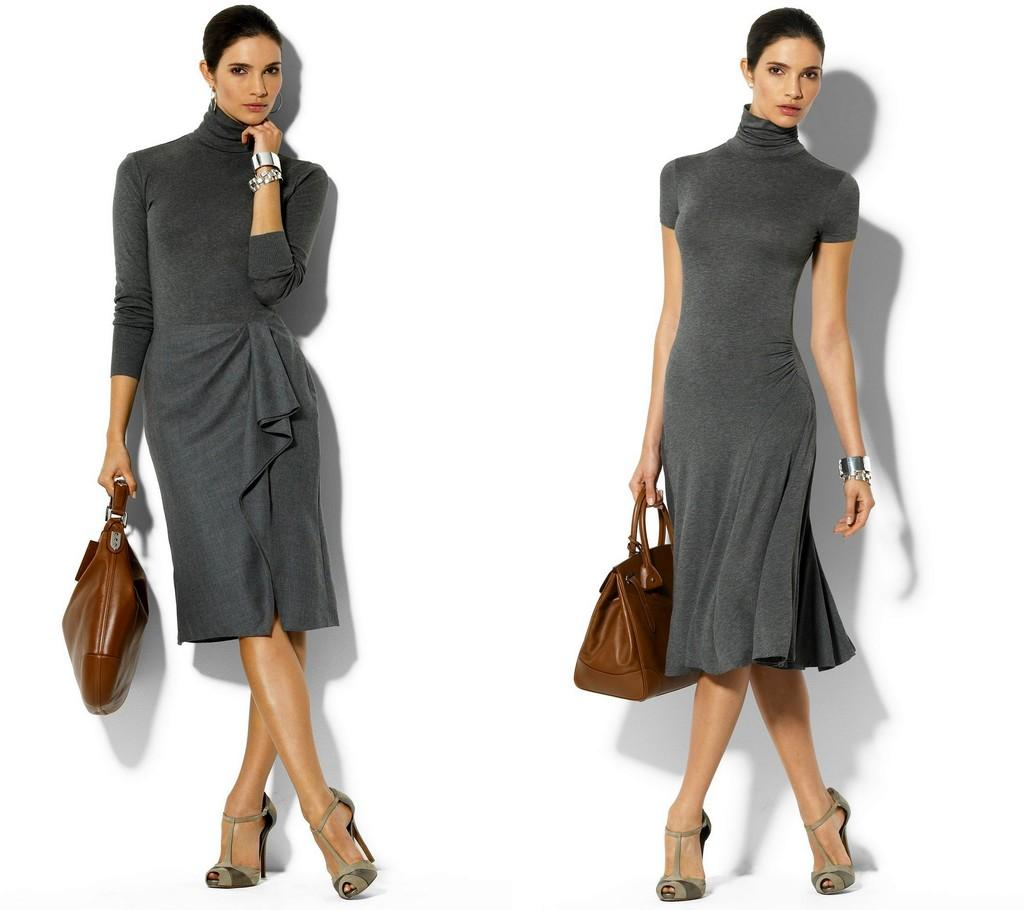How many women are in the image? There are two women in the image. What are the women wearing? The women are wearing grey color frocks. What are the women holding in their hands? The women are holding bags in their left hands. What position are the women in? The women are standing. What type of produce can be seen in the image? There is no produce present in the image. Can you tell me which woman is playing the guitar in the image? There is no guitar present in the image. 